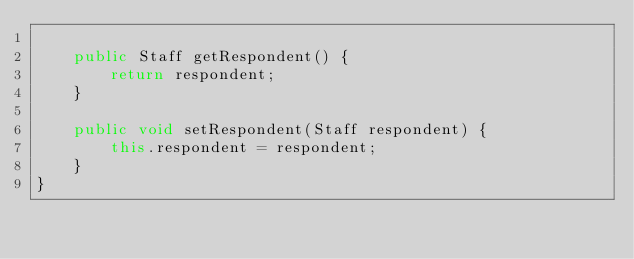<code> <loc_0><loc_0><loc_500><loc_500><_Java_>
    public Staff getRespondent() {
        return respondent;
    }

    public void setRespondent(Staff respondent) {
        this.respondent = respondent;
    }
}
</code> 